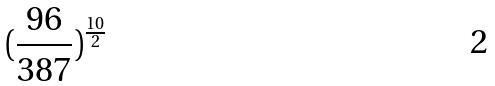<formula> <loc_0><loc_0><loc_500><loc_500>( \frac { 9 6 } { 3 8 7 } ) ^ { \frac { 1 0 } { 2 } }</formula> 